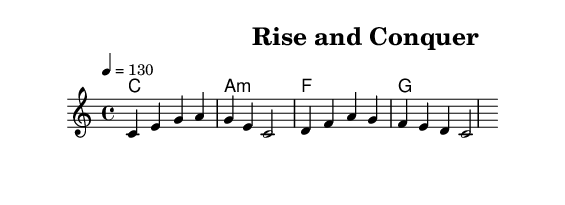What is the key signature of this music? The key signature of the piece is C major, which is indicated with no sharps or flats. C major is known for its absence of accidentals.
Answer: C major What is the time signature of this music? The time signature is indicated as 4/4, which means there are four beats in each measure and a quarter note receives one beat. This is a common time signature for dance music.
Answer: 4/4 What is the tempo marking of this music? The tempo marking indicates a speed of 130 beats per minute, which is suitable for maintaining an energetic pace during training sessions. This tempo encourages movement and motivation.
Answer: 130 How many measures are in the melody? By counting the measures in the melody section, we see that there are four measures present. This indicates the structure of the piece, which is common in dance music to maintain a repetitive and engaging feel.
Answer: 4 What is the primary chord progression used in the harmonies? The primarily used chord progression is C, A minor, F, and G. This progression is common in dance music, creating a sense of uplifting energy and motivation through its harmonious structure.
Answer: C, A minor, F, G What do the lyrics suggest about the theme of the song? The lyrics suggest a theme of perseverance and determination, encouraging listeners to push through challenges while training, which is fitting for motivational dance music. The phrases focus on overcoming obstacles effectively.
Answer: Perseverance What is the last note of the melody? The last note of the melody is a C. This note helps resolve the melody and provides a sense of closure, which is often important in music to signify the end of a phrase or section.
Answer: C 